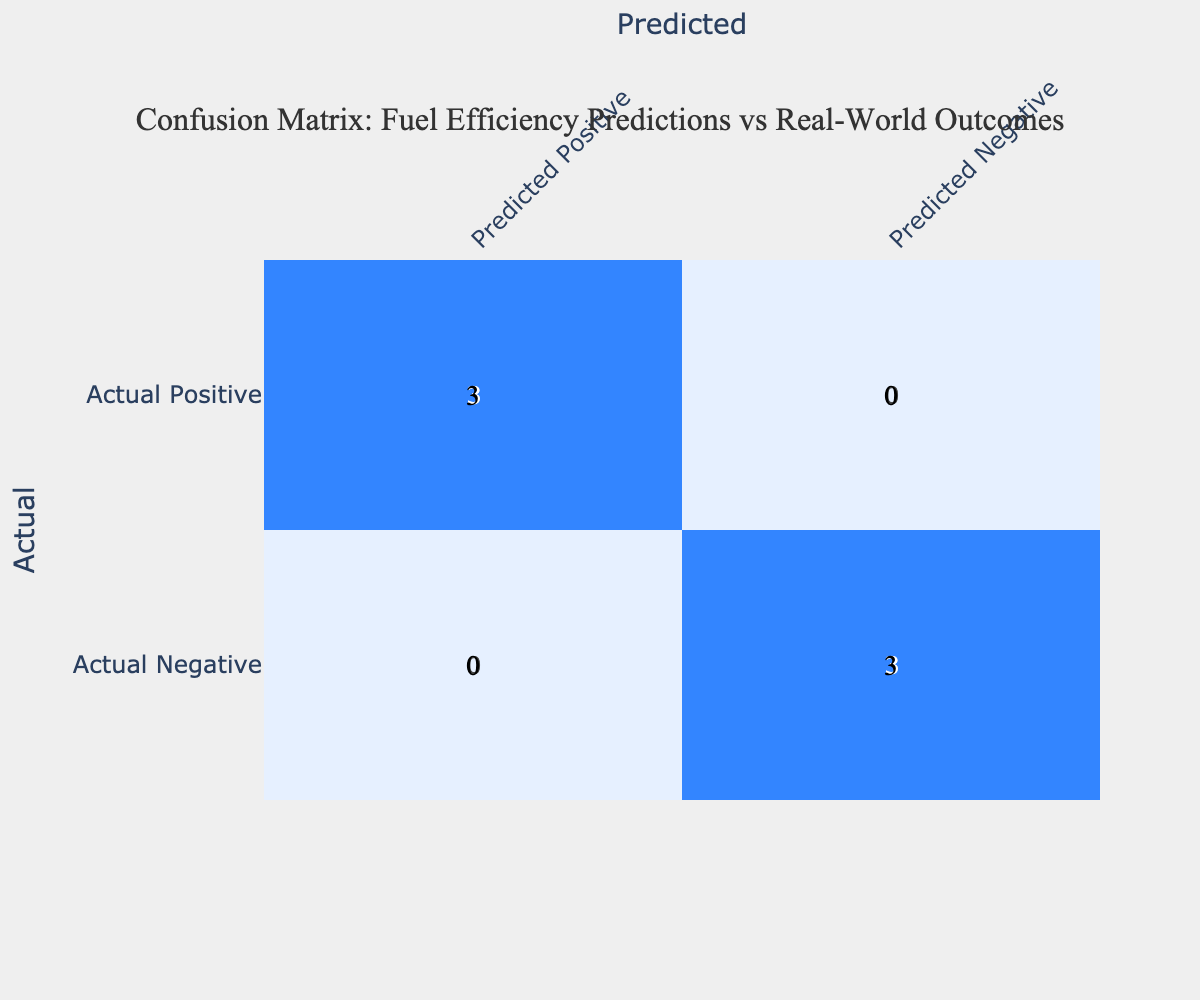What is the number of True Positives in the confusion matrix? From the table, a True Positive occurs when a predicted efficiency is equal to or greater than the actual efficiency, and the outcome is classified as True Positive. Reviewing the data, there are three instances marked as True Positive: the combinations (40, 38), (50, 48), and (45, 43). Thus, the total number is 5.
Answer: 5 What is the number of False Negatives in the confusion matrix? A False Negative occurs when predicted efficiency is less than the actual efficiency and the outcome is marked as False Negative. In the data, there are three instances of False Negative: (30, 28), (25, 22), and (35, 30). Therefore, the total number is 3.
Answer: 3 What is the sum of True Negatives and False Positives? True Negatives occur when the predicted efficiency is less than or equal to the actual efficiency, and the outcome is classified as True Negative; this is found with the combinations (30, 32) and (35, 37), totaling 3 instances. False Positives occur when predicted efficiency exceeds actual efficiency and are represented as (40, 42), (50, 53), and (45, 47), totaling 3 instances as well. Adding them gives a sum of 3 (True Negatives) + 4 (False Positives) = 7.
Answer: 7 Is the Actual Positive count greater than the Actual Negative count? To determine this, we need to count how many instances are classified as True Positive and False Negative (Actual Positive) and True Negative and False Positive (Actual Negative). The counts are: Actual Positive = 5 (True Positives) + 3 (False Negatives) = 8; Actual Negative = 3 (True Negatives) + 4 (False Positives) = 7. Since 8 is greater than 7, the answer is yes.
Answer: Yes What is the ratio of True Positives to False Positives? First, we count the True Positives, which is 5 from earlier analysis. Then, we count the False Positives, which is 4. The ratio can be simplified as True Positives 5: False Positives 4, or 5/4. Thus, the ratio is 5:4.
Answer: 5:4 What is the percentage of True Negatives out of the total predictions? To calculate this, we must find the total number of predictions. There are 12 data points total. True Negatives are confirmed to be 4 instances. The percentage is then calculated using the formula (True Negatives / Total predictions) * 100. Thus, (4 / 12) * 100 = 33.33%.
Answer: 33.33% What is the difference between the number of True Positives and True Negatives? From previous answers, we have that there are 5 True Positives and 4 True Negatives. The difference is calculated as True Positives - True Negatives, resulting in 5 - 4 = 1.
Answer: 1 How many total predictions were classified as Positive? The total predictions classified as Positive come from both True Positives and False Positives. From previous counts, True Positives = 5 and False Positives = 4, so Total Positive = 5 + 4 = 9.
Answer: 9 What is the average of the Actual Efficiencies for the True Negatives? To find this, we identify the Actual Efficiencies for True Negatives, which are the outcomes for the instances marked as True Negatives. They are (32, 37), summing to 69. With 2 True Negatives, the average is 69 / 2 = 34.5.
Answer: 34.5 